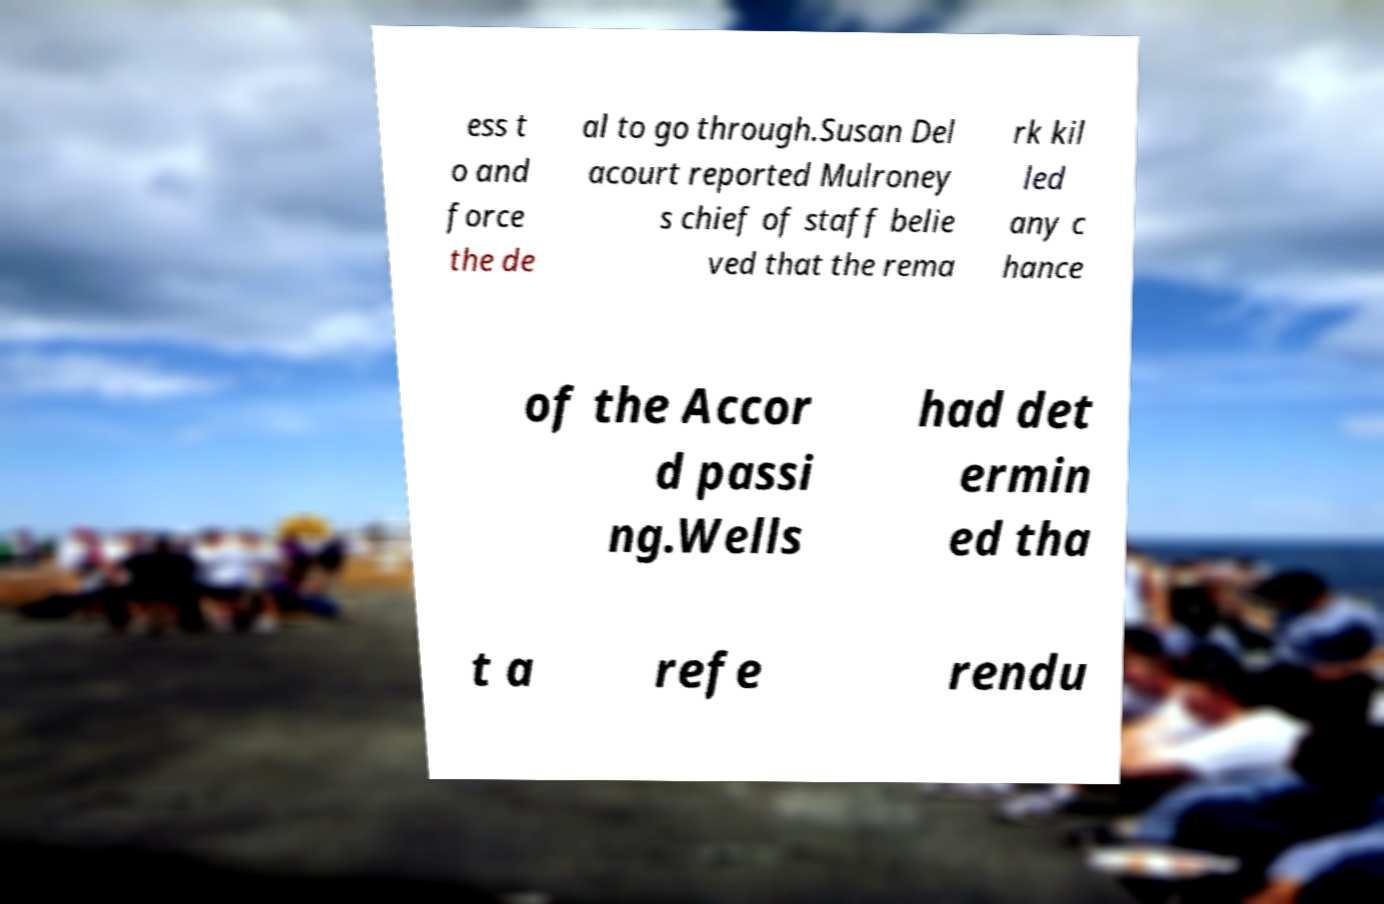Please read and relay the text visible in this image. What does it say? ess t o and force the de al to go through.Susan Del acourt reported Mulroney s chief of staff belie ved that the rema rk kil led any c hance of the Accor d passi ng.Wells had det ermin ed tha t a refe rendu 